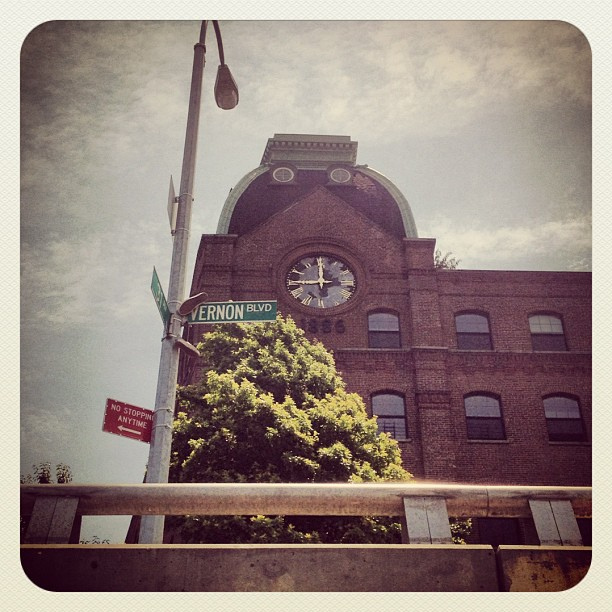What might have been the original use of this building, given its design and structure? The design suggests that this could have been a factory or warehouse originally, as indicated by the large windows for natural light and the robust construction typical of industrial buildings from the past. 